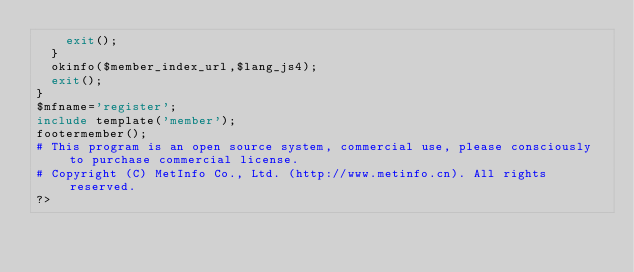Convert code to text. <code><loc_0><loc_0><loc_500><loc_500><_PHP_>		exit();
	}
	okinfo($member_index_url,$lang_js4);
	exit();
}
$mfname='register';
include template('member');
footermember();
# This program is an open source system, commercial use, please consciously to purchase commercial license.
# Copyright (C) MetInfo Co., Ltd. (http://www.metinfo.cn). All rights reserved.
?></code> 